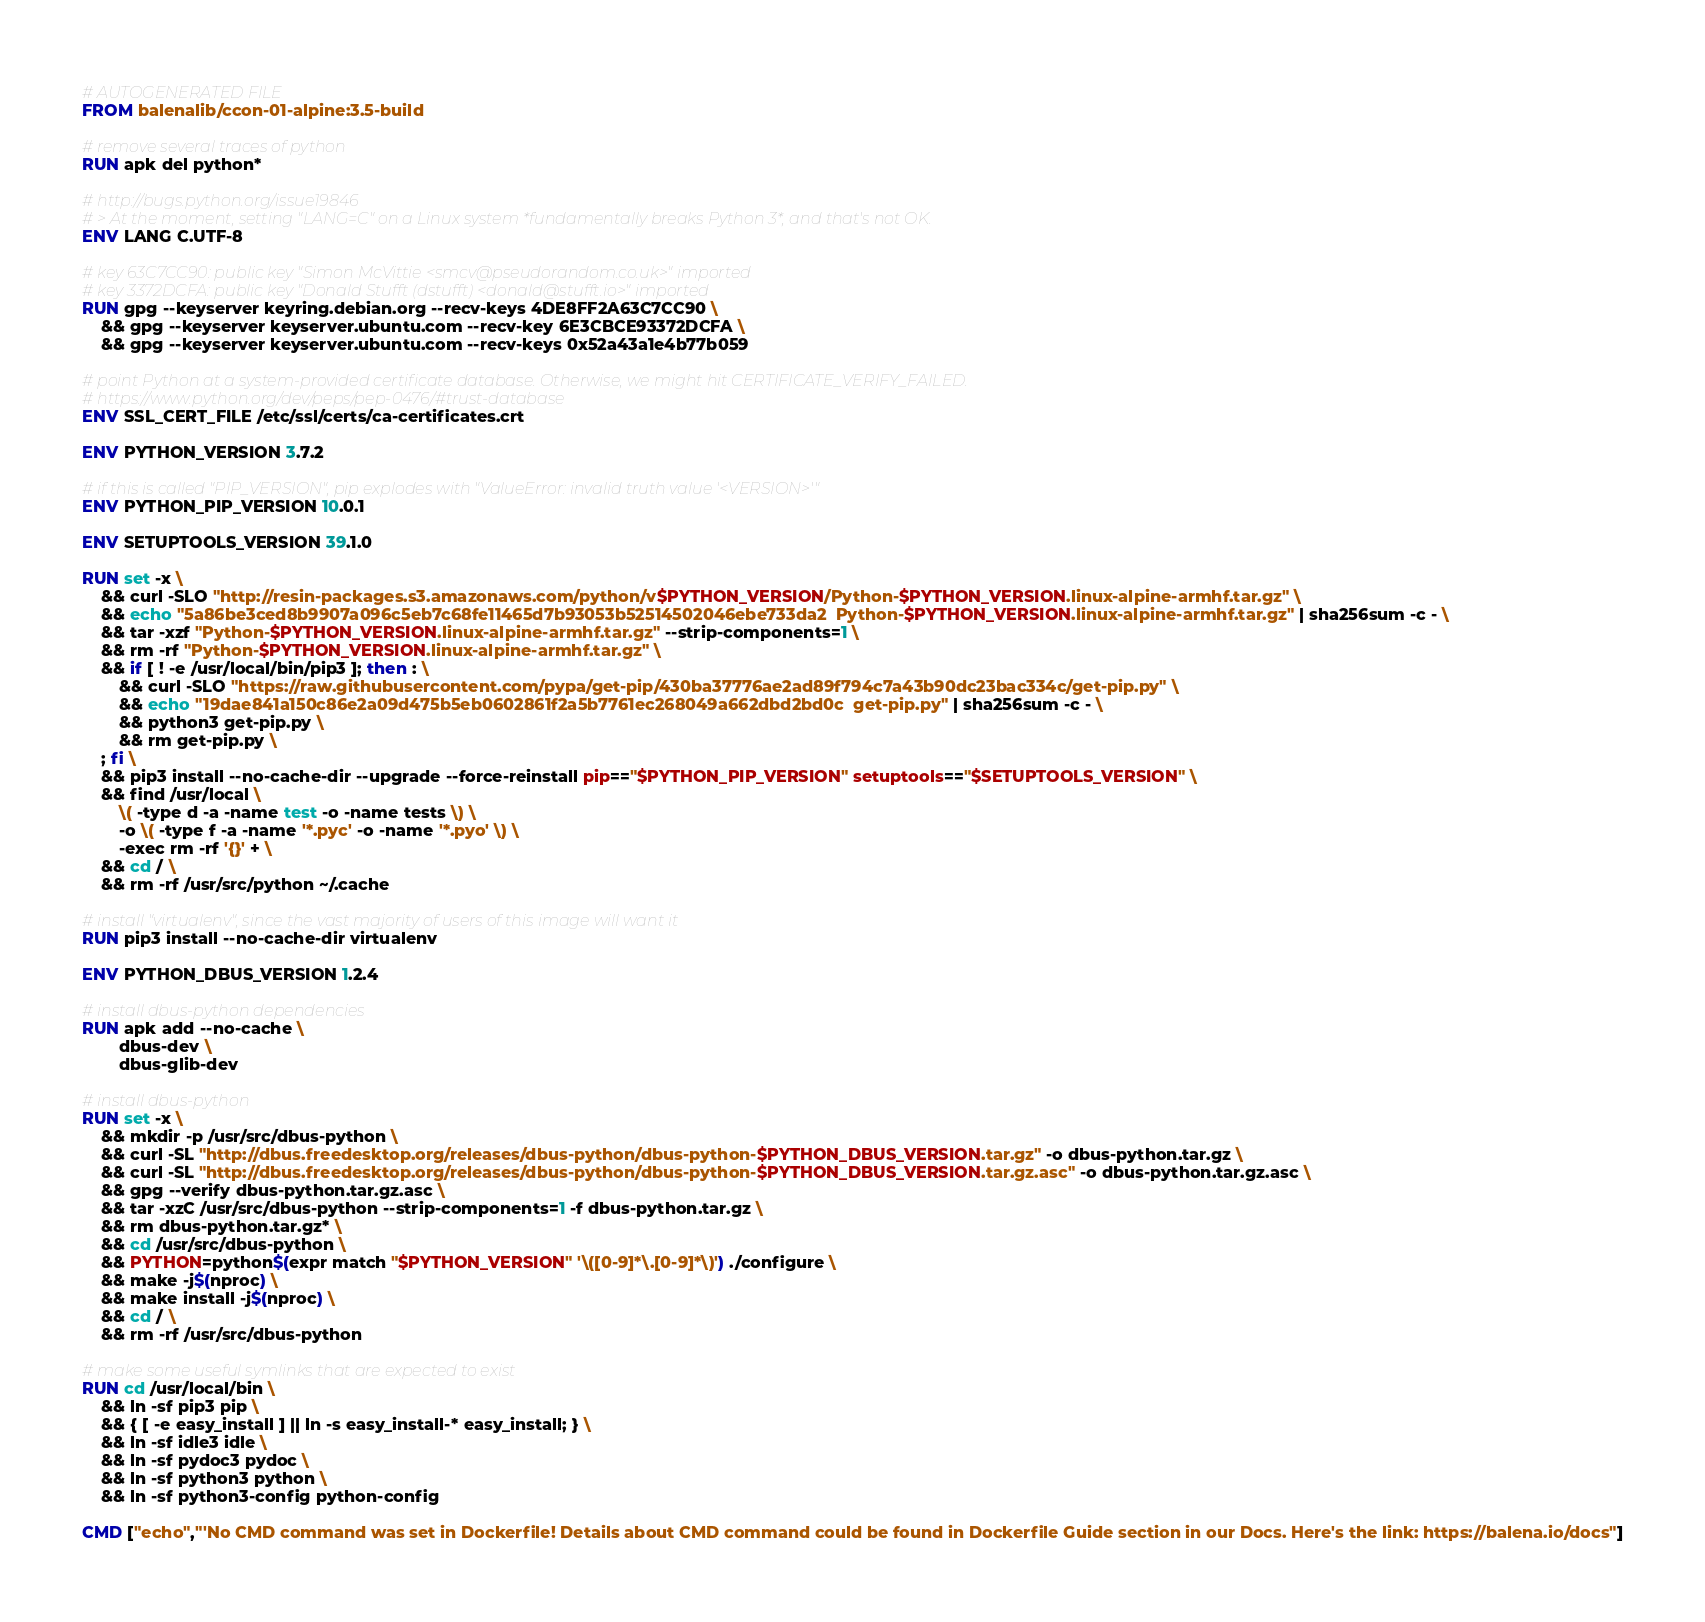<code> <loc_0><loc_0><loc_500><loc_500><_Dockerfile_># AUTOGENERATED FILE
FROM balenalib/ccon-01-alpine:3.5-build

# remove several traces of python
RUN apk del python*

# http://bugs.python.org/issue19846
# > At the moment, setting "LANG=C" on a Linux system *fundamentally breaks Python 3*, and that's not OK.
ENV LANG C.UTF-8

# key 63C7CC90: public key "Simon McVittie <smcv@pseudorandom.co.uk>" imported
# key 3372DCFA: public key "Donald Stufft (dstufft) <donald@stufft.io>" imported
RUN gpg --keyserver keyring.debian.org --recv-keys 4DE8FF2A63C7CC90 \
	&& gpg --keyserver keyserver.ubuntu.com --recv-key 6E3CBCE93372DCFA \
	&& gpg --keyserver keyserver.ubuntu.com --recv-keys 0x52a43a1e4b77b059

# point Python at a system-provided certificate database. Otherwise, we might hit CERTIFICATE_VERIFY_FAILED.
# https://www.python.org/dev/peps/pep-0476/#trust-database
ENV SSL_CERT_FILE /etc/ssl/certs/ca-certificates.crt

ENV PYTHON_VERSION 3.7.2

# if this is called "PIP_VERSION", pip explodes with "ValueError: invalid truth value '<VERSION>'"
ENV PYTHON_PIP_VERSION 10.0.1

ENV SETUPTOOLS_VERSION 39.1.0

RUN set -x \
	&& curl -SLO "http://resin-packages.s3.amazonaws.com/python/v$PYTHON_VERSION/Python-$PYTHON_VERSION.linux-alpine-armhf.tar.gz" \
	&& echo "5a86be3ced8b9907a096c5eb7c68fe11465d7b93053b52514502046ebe733da2  Python-$PYTHON_VERSION.linux-alpine-armhf.tar.gz" | sha256sum -c - \
	&& tar -xzf "Python-$PYTHON_VERSION.linux-alpine-armhf.tar.gz" --strip-components=1 \
	&& rm -rf "Python-$PYTHON_VERSION.linux-alpine-armhf.tar.gz" \
	&& if [ ! -e /usr/local/bin/pip3 ]; then : \
		&& curl -SLO "https://raw.githubusercontent.com/pypa/get-pip/430ba37776ae2ad89f794c7a43b90dc23bac334c/get-pip.py" \
		&& echo "19dae841a150c86e2a09d475b5eb0602861f2a5b7761ec268049a662dbd2bd0c  get-pip.py" | sha256sum -c - \
		&& python3 get-pip.py \
		&& rm get-pip.py \
	; fi \
	&& pip3 install --no-cache-dir --upgrade --force-reinstall pip=="$PYTHON_PIP_VERSION" setuptools=="$SETUPTOOLS_VERSION" \
	&& find /usr/local \
		\( -type d -a -name test -o -name tests \) \
		-o \( -type f -a -name '*.pyc' -o -name '*.pyo' \) \
		-exec rm -rf '{}' + \
	&& cd / \
	&& rm -rf /usr/src/python ~/.cache

# install "virtualenv", since the vast majority of users of this image will want it
RUN pip3 install --no-cache-dir virtualenv

ENV PYTHON_DBUS_VERSION 1.2.4

# install dbus-python dependencies 
RUN apk add --no-cache \
		dbus-dev \
		dbus-glib-dev

# install dbus-python
RUN set -x \
	&& mkdir -p /usr/src/dbus-python \
	&& curl -SL "http://dbus.freedesktop.org/releases/dbus-python/dbus-python-$PYTHON_DBUS_VERSION.tar.gz" -o dbus-python.tar.gz \
	&& curl -SL "http://dbus.freedesktop.org/releases/dbus-python/dbus-python-$PYTHON_DBUS_VERSION.tar.gz.asc" -o dbus-python.tar.gz.asc \
	&& gpg --verify dbus-python.tar.gz.asc \
	&& tar -xzC /usr/src/dbus-python --strip-components=1 -f dbus-python.tar.gz \
	&& rm dbus-python.tar.gz* \
	&& cd /usr/src/dbus-python \
	&& PYTHON=python$(expr match "$PYTHON_VERSION" '\([0-9]*\.[0-9]*\)') ./configure \
	&& make -j$(nproc) \
	&& make install -j$(nproc) \
	&& cd / \
	&& rm -rf /usr/src/dbus-python

# make some useful symlinks that are expected to exist
RUN cd /usr/local/bin \
	&& ln -sf pip3 pip \
	&& { [ -e easy_install ] || ln -s easy_install-* easy_install; } \
	&& ln -sf idle3 idle \
	&& ln -sf pydoc3 pydoc \
	&& ln -sf python3 python \
	&& ln -sf python3-config python-config

CMD ["echo","'No CMD command was set in Dockerfile! Details about CMD command could be found in Dockerfile Guide section in our Docs. Here's the link: https://balena.io/docs"]</code> 